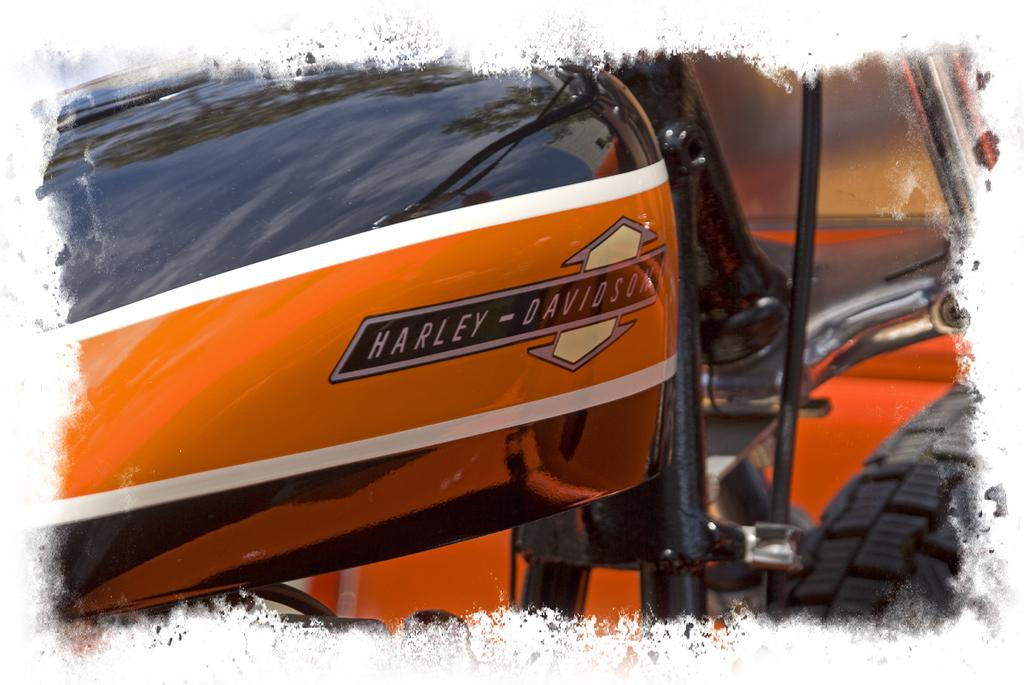What can be observed about the image's appearance? The image is edited. What is the main subject in the center of the image? There is a bike in the center of the image. What type of clover is growing near the bike in the image? There is no clover present in the image; it only features a bike in the center. 